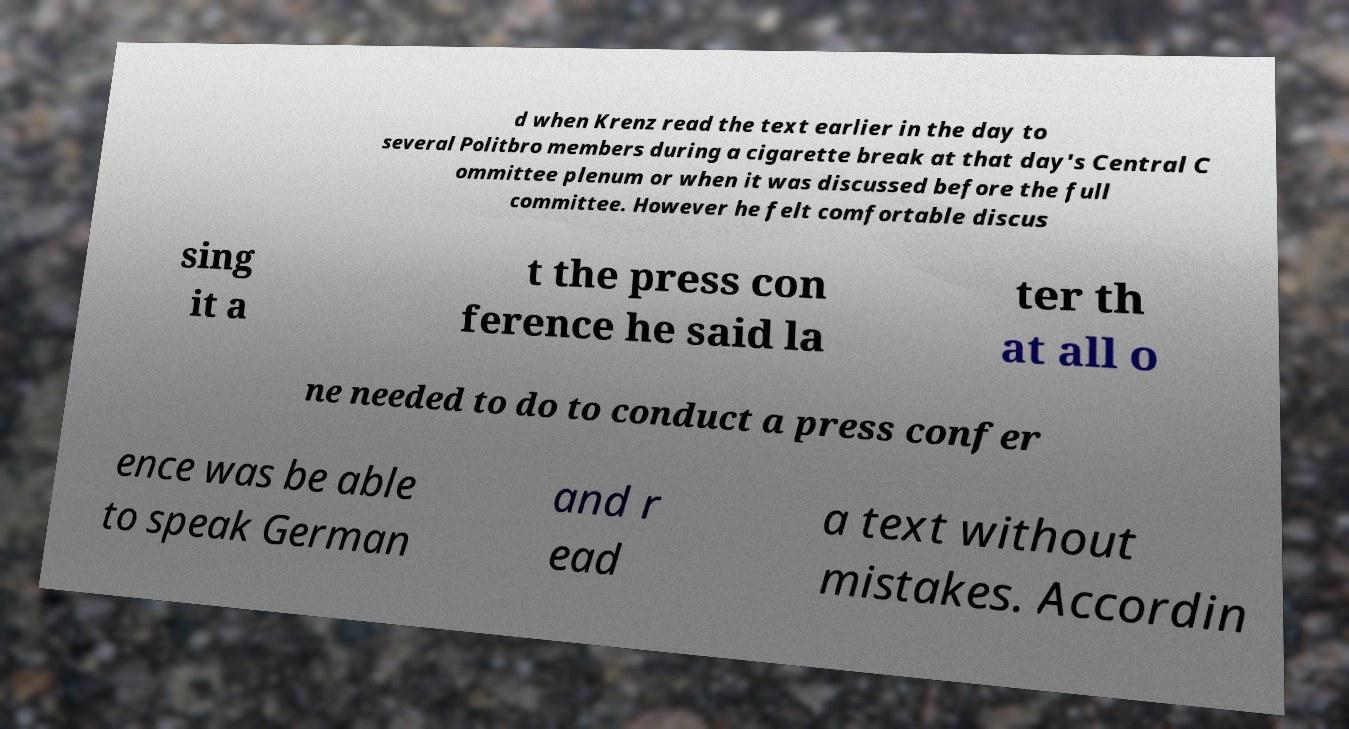Could you assist in decoding the text presented in this image and type it out clearly? d when Krenz read the text earlier in the day to several Politbro members during a cigarette break at that day's Central C ommittee plenum or when it was discussed before the full committee. However he felt comfortable discus sing it a t the press con ference he said la ter th at all o ne needed to do to conduct a press confer ence was be able to speak German and r ead a text without mistakes. Accordin 